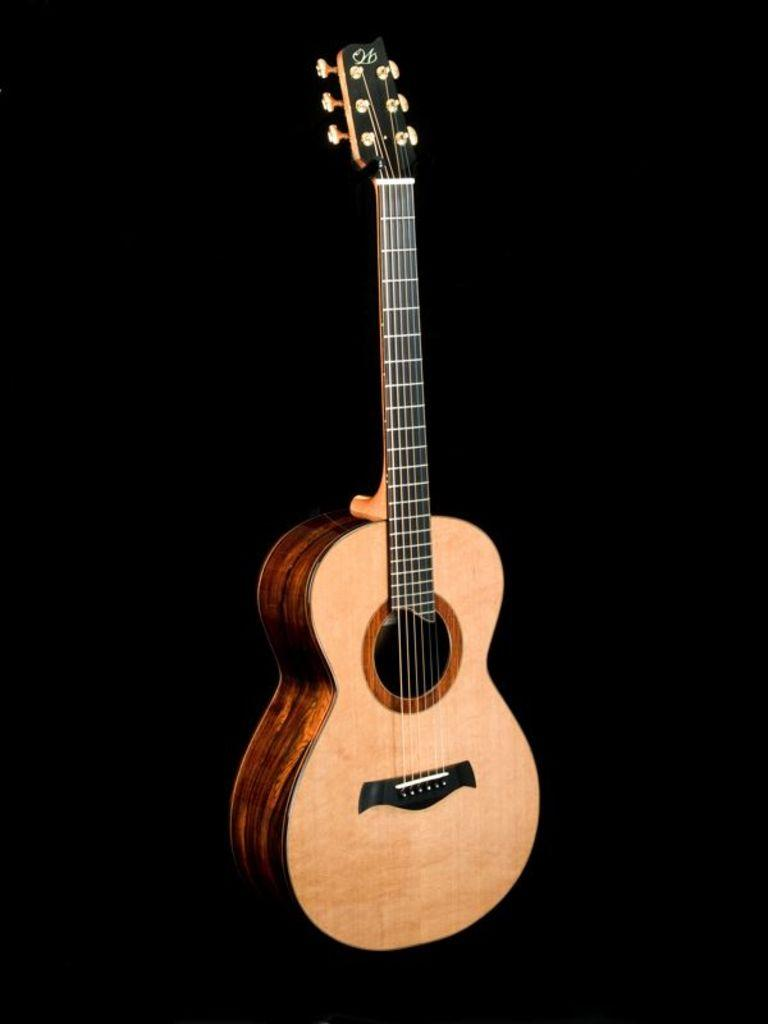What musical instrument is present in the image? There is a guitar in the image. What type of strings does the guitar have? The guitar in the image has six strings. What is the guitar's primary function? The guitar's primary function is to be played as a musical instrument. What part of the guitar is typically used to produce sound? The guitar's sound is produced by strumming or plucking the strings. What type of fuel is required to power the guitar in the image? There is no fuel required to power the guitar in the image, as it is an acoustic instrument that produces sound through the vibration of its strings. 